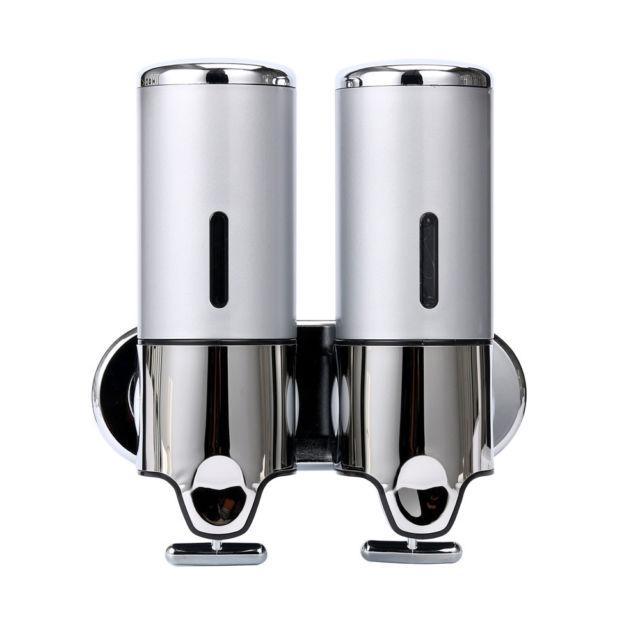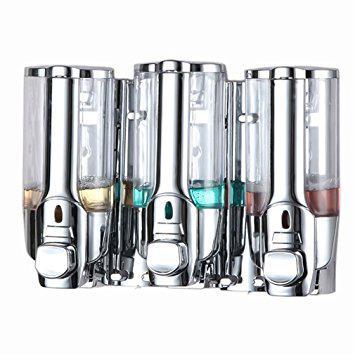The first image is the image on the left, the second image is the image on the right. Examine the images to the left and right. Is the description "At least one soap dispenser has a pump on top." accurate? Answer yes or no. No. The first image is the image on the left, the second image is the image on the right. For the images shown, is this caption "One image features an opaque dispenser style with a top nozzle, and the other features a style that dispenses from the bottom and has a clear body." true? Answer yes or no. No. 